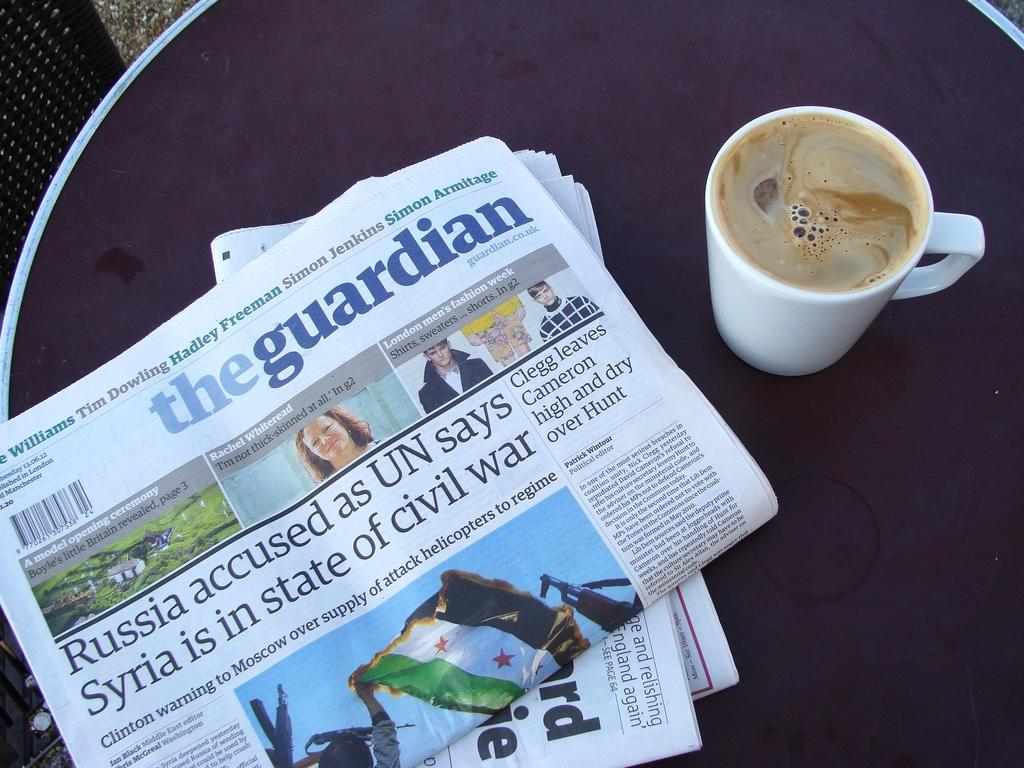What type of reading material is present in the image? There are newspapers in the image. What is the other item placed on the table with the newspapers? There is a coffee mug in the image. Where are the newspapers and coffee mug located? They are placed on a table. What piece of furniture is visible at the left side of the image? There is a chair at the left side of the image. How many rabbits can be seen playing with the newspapers in the image? There are no rabbits present in the image; it only features newspapers and a coffee mug on a table. What type of sorting activity is being performed with the newspapers in the image? There is no sorting activity being performed with the newspapers in the image; they are simply placed on a table. 